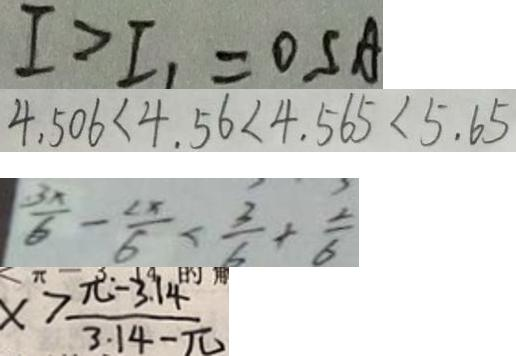<formula> <loc_0><loc_0><loc_500><loc_500>I > I _ { 1 } = 0 S A 
 4 . 5 0 6 < 4 . 5 6 < 4 . 5 6 5 < 5 . 6 5 
 \frac { 3 x } { 6 } - \frac { 2 x } { 6 } < \frac { 3 } { 5 } + \frac { 2 } { 6 } 
 x > \frac { \pi - 3 . 1 4 } { 3 . 1 4 - \pi }</formula> 